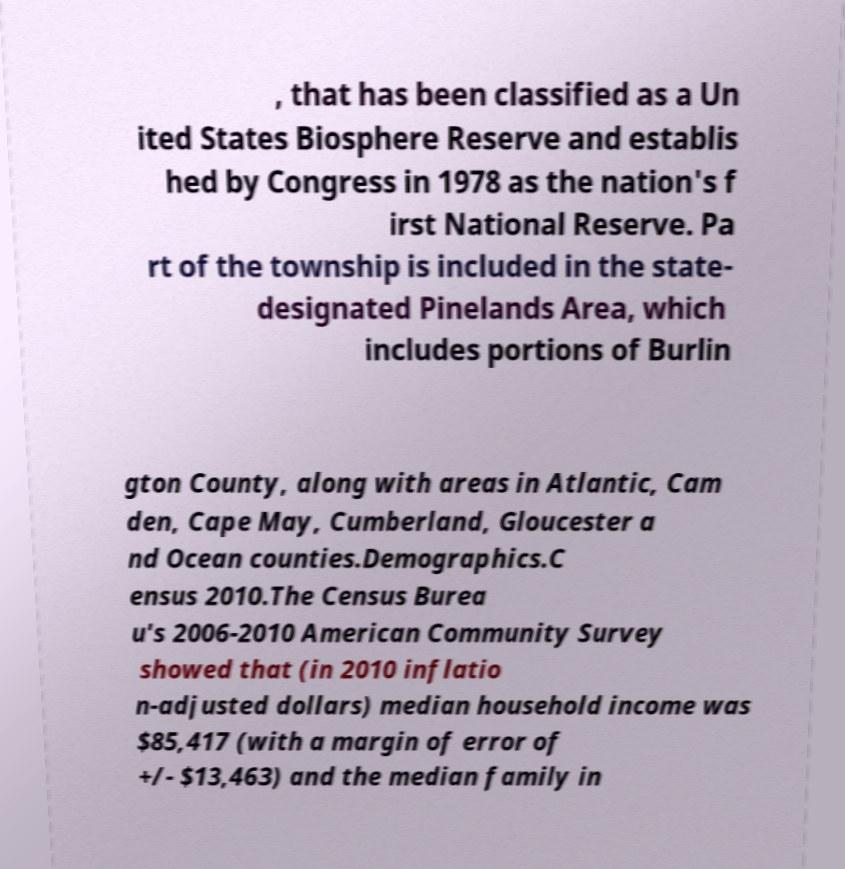Could you extract and type out the text from this image? , that has been classified as a Un ited States Biosphere Reserve and establis hed by Congress in 1978 as the nation's f irst National Reserve. Pa rt of the township is included in the state- designated Pinelands Area, which includes portions of Burlin gton County, along with areas in Atlantic, Cam den, Cape May, Cumberland, Gloucester a nd Ocean counties.Demographics.C ensus 2010.The Census Burea u's 2006-2010 American Community Survey showed that (in 2010 inflatio n-adjusted dollars) median household income was $85,417 (with a margin of error of +/- $13,463) and the median family in 